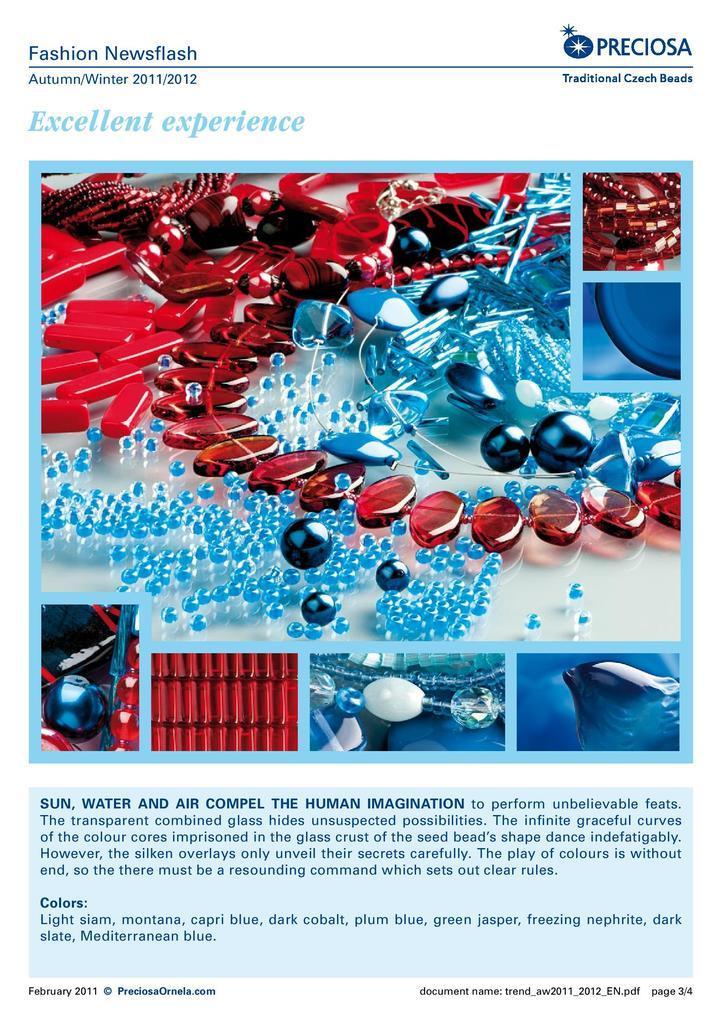How would you summarize this image in a sentence or two? In this image we can see a magazine. On the top and bottom of the image we can see text. 